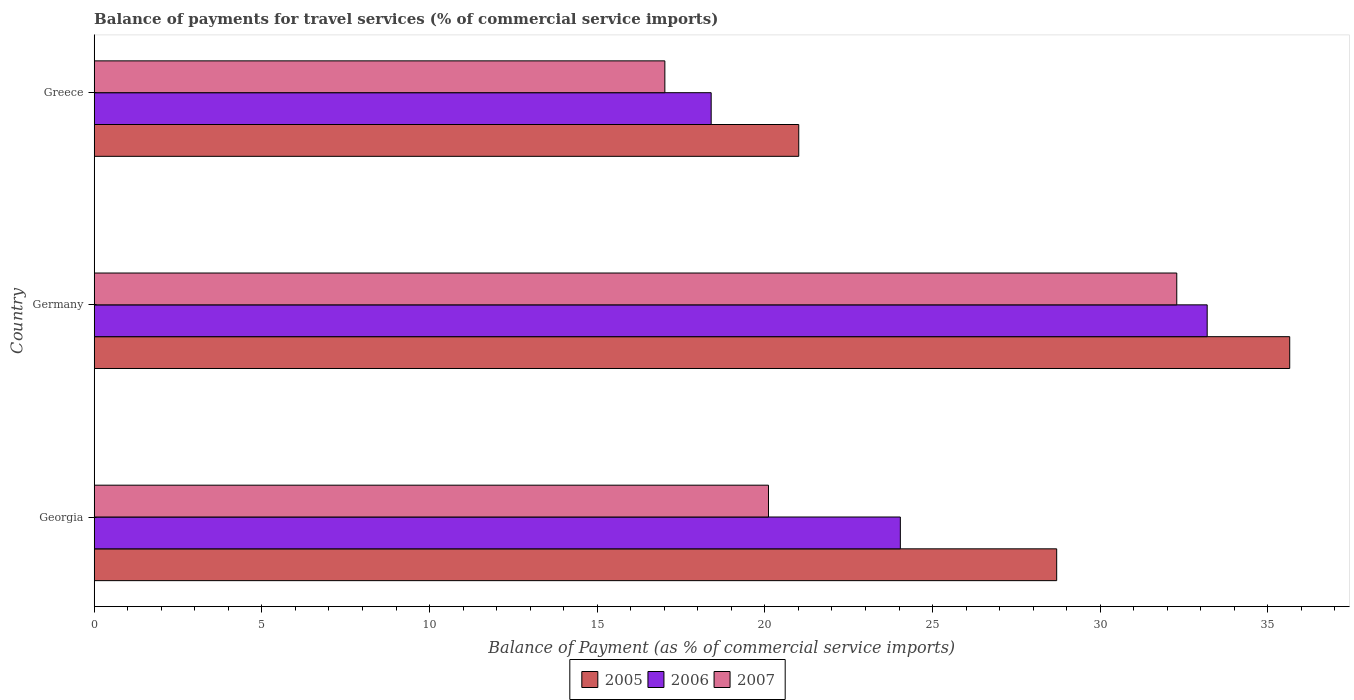Are the number of bars on each tick of the Y-axis equal?
Your answer should be very brief. Yes. What is the balance of payments for travel services in 2005 in Germany?
Keep it short and to the point. 35.65. Across all countries, what is the maximum balance of payments for travel services in 2006?
Ensure brevity in your answer.  33.19. Across all countries, what is the minimum balance of payments for travel services in 2006?
Provide a succinct answer. 18.4. In which country was the balance of payments for travel services in 2007 maximum?
Give a very brief answer. Germany. In which country was the balance of payments for travel services in 2007 minimum?
Offer a very short reply. Greece. What is the total balance of payments for travel services in 2005 in the graph?
Your response must be concise. 85.36. What is the difference between the balance of payments for travel services in 2007 in Georgia and that in Germany?
Give a very brief answer. -12.18. What is the difference between the balance of payments for travel services in 2005 in Greece and the balance of payments for travel services in 2007 in Georgia?
Offer a very short reply. 0.9. What is the average balance of payments for travel services in 2006 per country?
Keep it short and to the point. 25.21. What is the difference between the balance of payments for travel services in 2007 and balance of payments for travel services in 2005 in Germany?
Provide a short and direct response. -3.37. In how many countries, is the balance of payments for travel services in 2007 greater than 8 %?
Offer a very short reply. 3. What is the ratio of the balance of payments for travel services in 2007 in Germany to that in Greece?
Offer a terse response. 1.9. What is the difference between the highest and the second highest balance of payments for travel services in 2006?
Your answer should be very brief. 9.15. What is the difference between the highest and the lowest balance of payments for travel services in 2007?
Keep it short and to the point. 15.27. What does the 2nd bar from the top in Germany represents?
Your response must be concise. 2006. What does the 2nd bar from the bottom in Georgia represents?
Give a very brief answer. 2006. How many bars are there?
Your answer should be compact. 9. Are all the bars in the graph horizontal?
Provide a succinct answer. Yes. Does the graph contain any zero values?
Provide a succinct answer. No. Where does the legend appear in the graph?
Offer a terse response. Bottom center. How many legend labels are there?
Keep it short and to the point. 3. How are the legend labels stacked?
Offer a very short reply. Horizontal. What is the title of the graph?
Provide a succinct answer. Balance of payments for travel services (% of commercial service imports). What is the label or title of the X-axis?
Make the answer very short. Balance of Payment (as % of commercial service imports). What is the label or title of the Y-axis?
Keep it short and to the point. Country. What is the Balance of Payment (as % of commercial service imports) in 2005 in Georgia?
Keep it short and to the point. 28.7. What is the Balance of Payment (as % of commercial service imports) in 2006 in Georgia?
Provide a short and direct response. 24.04. What is the Balance of Payment (as % of commercial service imports) in 2007 in Georgia?
Ensure brevity in your answer.  20.11. What is the Balance of Payment (as % of commercial service imports) of 2005 in Germany?
Your answer should be compact. 35.65. What is the Balance of Payment (as % of commercial service imports) in 2006 in Germany?
Provide a short and direct response. 33.19. What is the Balance of Payment (as % of commercial service imports) of 2007 in Germany?
Make the answer very short. 32.28. What is the Balance of Payment (as % of commercial service imports) in 2005 in Greece?
Make the answer very short. 21.01. What is the Balance of Payment (as % of commercial service imports) of 2006 in Greece?
Keep it short and to the point. 18.4. What is the Balance of Payment (as % of commercial service imports) of 2007 in Greece?
Your answer should be compact. 17.02. Across all countries, what is the maximum Balance of Payment (as % of commercial service imports) of 2005?
Keep it short and to the point. 35.65. Across all countries, what is the maximum Balance of Payment (as % of commercial service imports) of 2006?
Ensure brevity in your answer.  33.19. Across all countries, what is the maximum Balance of Payment (as % of commercial service imports) of 2007?
Ensure brevity in your answer.  32.28. Across all countries, what is the minimum Balance of Payment (as % of commercial service imports) in 2005?
Offer a terse response. 21.01. Across all countries, what is the minimum Balance of Payment (as % of commercial service imports) in 2006?
Make the answer very short. 18.4. Across all countries, what is the minimum Balance of Payment (as % of commercial service imports) of 2007?
Your answer should be compact. 17.02. What is the total Balance of Payment (as % of commercial service imports) of 2005 in the graph?
Ensure brevity in your answer.  85.36. What is the total Balance of Payment (as % of commercial service imports) in 2006 in the graph?
Provide a succinct answer. 75.63. What is the total Balance of Payment (as % of commercial service imports) in 2007 in the graph?
Give a very brief answer. 69.41. What is the difference between the Balance of Payment (as % of commercial service imports) in 2005 in Georgia and that in Germany?
Provide a short and direct response. -6.95. What is the difference between the Balance of Payment (as % of commercial service imports) of 2006 in Georgia and that in Germany?
Your response must be concise. -9.15. What is the difference between the Balance of Payment (as % of commercial service imports) of 2007 in Georgia and that in Germany?
Your answer should be compact. -12.18. What is the difference between the Balance of Payment (as % of commercial service imports) in 2005 in Georgia and that in Greece?
Provide a short and direct response. 7.69. What is the difference between the Balance of Payment (as % of commercial service imports) of 2006 in Georgia and that in Greece?
Offer a very short reply. 5.64. What is the difference between the Balance of Payment (as % of commercial service imports) in 2007 in Georgia and that in Greece?
Offer a terse response. 3.09. What is the difference between the Balance of Payment (as % of commercial service imports) in 2005 in Germany and that in Greece?
Your answer should be very brief. 14.64. What is the difference between the Balance of Payment (as % of commercial service imports) in 2006 in Germany and that in Greece?
Give a very brief answer. 14.79. What is the difference between the Balance of Payment (as % of commercial service imports) in 2007 in Germany and that in Greece?
Give a very brief answer. 15.27. What is the difference between the Balance of Payment (as % of commercial service imports) in 2005 in Georgia and the Balance of Payment (as % of commercial service imports) in 2006 in Germany?
Provide a succinct answer. -4.49. What is the difference between the Balance of Payment (as % of commercial service imports) in 2005 in Georgia and the Balance of Payment (as % of commercial service imports) in 2007 in Germany?
Ensure brevity in your answer.  -3.58. What is the difference between the Balance of Payment (as % of commercial service imports) of 2006 in Georgia and the Balance of Payment (as % of commercial service imports) of 2007 in Germany?
Ensure brevity in your answer.  -8.24. What is the difference between the Balance of Payment (as % of commercial service imports) in 2005 in Georgia and the Balance of Payment (as % of commercial service imports) in 2006 in Greece?
Your answer should be very brief. 10.3. What is the difference between the Balance of Payment (as % of commercial service imports) of 2005 in Georgia and the Balance of Payment (as % of commercial service imports) of 2007 in Greece?
Provide a short and direct response. 11.69. What is the difference between the Balance of Payment (as % of commercial service imports) in 2006 in Georgia and the Balance of Payment (as % of commercial service imports) in 2007 in Greece?
Give a very brief answer. 7.02. What is the difference between the Balance of Payment (as % of commercial service imports) of 2005 in Germany and the Balance of Payment (as % of commercial service imports) of 2006 in Greece?
Provide a succinct answer. 17.25. What is the difference between the Balance of Payment (as % of commercial service imports) of 2005 in Germany and the Balance of Payment (as % of commercial service imports) of 2007 in Greece?
Your answer should be very brief. 18.63. What is the difference between the Balance of Payment (as % of commercial service imports) in 2006 in Germany and the Balance of Payment (as % of commercial service imports) in 2007 in Greece?
Keep it short and to the point. 16.17. What is the average Balance of Payment (as % of commercial service imports) in 2005 per country?
Offer a very short reply. 28.45. What is the average Balance of Payment (as % of commercial service imports) of 2006 per country?
Offer a very short reply. 25.21. What is the average Balance of Payment (as % of commercial service imports) of 2007 per country?
Make the answer very short. 23.14. What is the difference between the Balance of Payment (as % of commercial service imports) of 2005 and Balance of Payment (as % of commercial service imports) of 2006 in Georgia?
Ensure brevity in your answer.  4.66. What is the difference between the Balance of Payment (as % of commercial service imports) of 2005 and Balance of Payment (as % of commercial service imports) of 2007 in Georgia?
Your response must be concise. 8.59. What is the difference between the Balance of Payment (as % of commercial service imports) in 2006 and Balance of Payment (as % of commercial service imports) in 2007 in Georgia?
Provide a short and direct response. 3.93. What is the difference between the Balance of Payment (as % of commercial service imports) in 2005 and Balance of Payment (as % of commercial service imports) in 2006 in Germany?
Provide a succinct answer. 2.46. What is the difference between the Balance of Payment (as % of commercial service imports) in 2005 and Balance of Payment (as % of commercial service imports) in 2007 in Germany?
Keep it short and to the point. 3.37. What is the difference between the Balance of Payment (as % of commercial service imports) in 2006 and Balance of Payment (as % of commercial service imports) in 2007 in Germany?
Offer a very short reply. 0.91. What is the difference between the Balance of Payment (as % of commercial service imports) of 2005 and Balance of Payment (as % of commercial service imports) of 2006 in Greece?
Your response must be concise. 2.61. What is the difference between the Balance of Payment (as % of commercial service imports) of 2005 and Balance of Payment (as % of commercial service imports) of 2007 in Greece?
Your answer should be compact. 3.99. What is the difference between the Balance of Payment (as % of commercial service imports) in 2006 and Balance of Payment (as % of commercial service imports) in 2007 in Greece?
Make the answer very short. 1.38. What is the ratio of the Balance of Payment (as % of commercial service imports) of 2005 in Georgia to that in Germany?
Keep it short and to the point. 0.81. What is the ratio of the Balance of Payment (as % of commercial service imports) in 2006 in Georgia to that in Germany?
Your response must be concise. 0.72. What is the ratio of the Balance of Payment (as % of commercial service imports) in 2007 in Georgia to that in Germany?
Offer a terse response. 0.62. What is the ratio of the Balance of Payment (as % of commercial service imports) of 2005 in Georgia to that in Greece?
Your answer should be very brief. 1.37. What is the ratio of the Balance of Payment (as % of commercial service imports) in 2006 in Georgia to that in Greece?
Provide a succinct answer. 1.31. What is the ratio of the Balance of Payment (as % of commercial service imports) in 2007 in Georgia to that in Greece?
Give a very brief answer. 1.18. What is the ratio of the Balance of Payment (as % of commercial service imports) in 2005 in Germany to that in Greece?
Keep it short and to the point. 1.7. What is the ratio of the Balance of Payment (as % of commercial service imports) in 2006 in Germany to that in Greece?
Make the answer very short. 1.8. What is the ratio of the Balance of Payment (as % of commercial service imports) of 2007 in Germany to that in Greece?
Offer a very short reply. 1.9. What is the difference between the highest and the second highest Balance of Payment (as % of commercial service imports) in 2005?
Make the answer very short. 6.95. What is the difference between the highest and the second highest Balance of Payment (as % of commercial service imports) in 2006?
Ensure brevity in your answer.  9.15. What is the difference between the highest and the second highest Balance of Payment (as % of commercial service imports) in 2007?
Provide a succinct answer. 12.18. What is the difference between the highest and the lowest Balance of Payment (as % of commercial service imports) in 2005?
Provide a short and direct response. 14.64. What is the difference between the highest and the lowest Balance of Payment (as % of commercial service imports) of 2006?
Offer a terse response. 14.79. What is the difference between the highest and the lowest Balance of Payment (as % of commercial service imports) of 2007?
Ensure brevity in your answer.  15.27. 